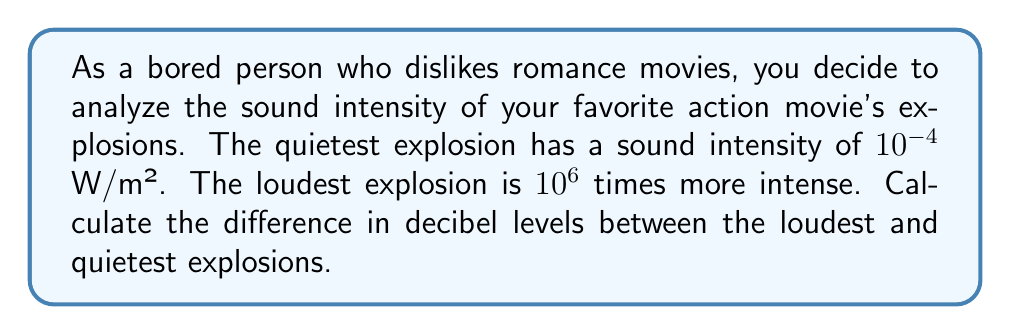Could you help me with this problem? To solve this problem, we'll use the formula for calculating decibel levels and the properties of logarithms.

1) The formula for sound intensity level in decibels is:

   $$ L = 10 \log_{10}\left(\frac{I}{I_0}\right) $$

   where $I$ is the sound intensity and $I_0$ is the reference intensity ($10^{-12}$ W/m²).

2) For the quietest explosion:
   $$ L_1 = 10 \log_{10}\left(\frac{10^{-4}}{10^{-12}}\right) = 10 \log_{10}(10^8) = 10 \cdot 8 = 80 \text{ dB} $$

3) For the loudest explosion:
   The intensity is $10^6$ times greater, so $I_2 = 10^{-4} \cdot 10^6 = 10^2$ W/m²
   $$ L_2 = 10 \log_{10}\left(\frac{10^2}{10^{-12}}\right) = 10 \log_{10}(10^{14}) = 10 \cdot 14 = 140 \text{ dB} $$

4) The difference in decibel levels:
   $$ \Delta L = L_2 - L_1 = 140 - 80 = 60 \text{ dB} $$

Alternatively, we could have used the logarithm property $\log_a(x^n) = n\log_a(x)$:

$$ \Delta L = 10 \log_{10}\left(\frac{I_2}{I_1}\right) = 10 \log_{10}(10^6) = 10 \cdot 6 = 60 \text{ dB} $$
Answer: The difference in decibel levels between the loudest and quietest explosions is 60 dB. 